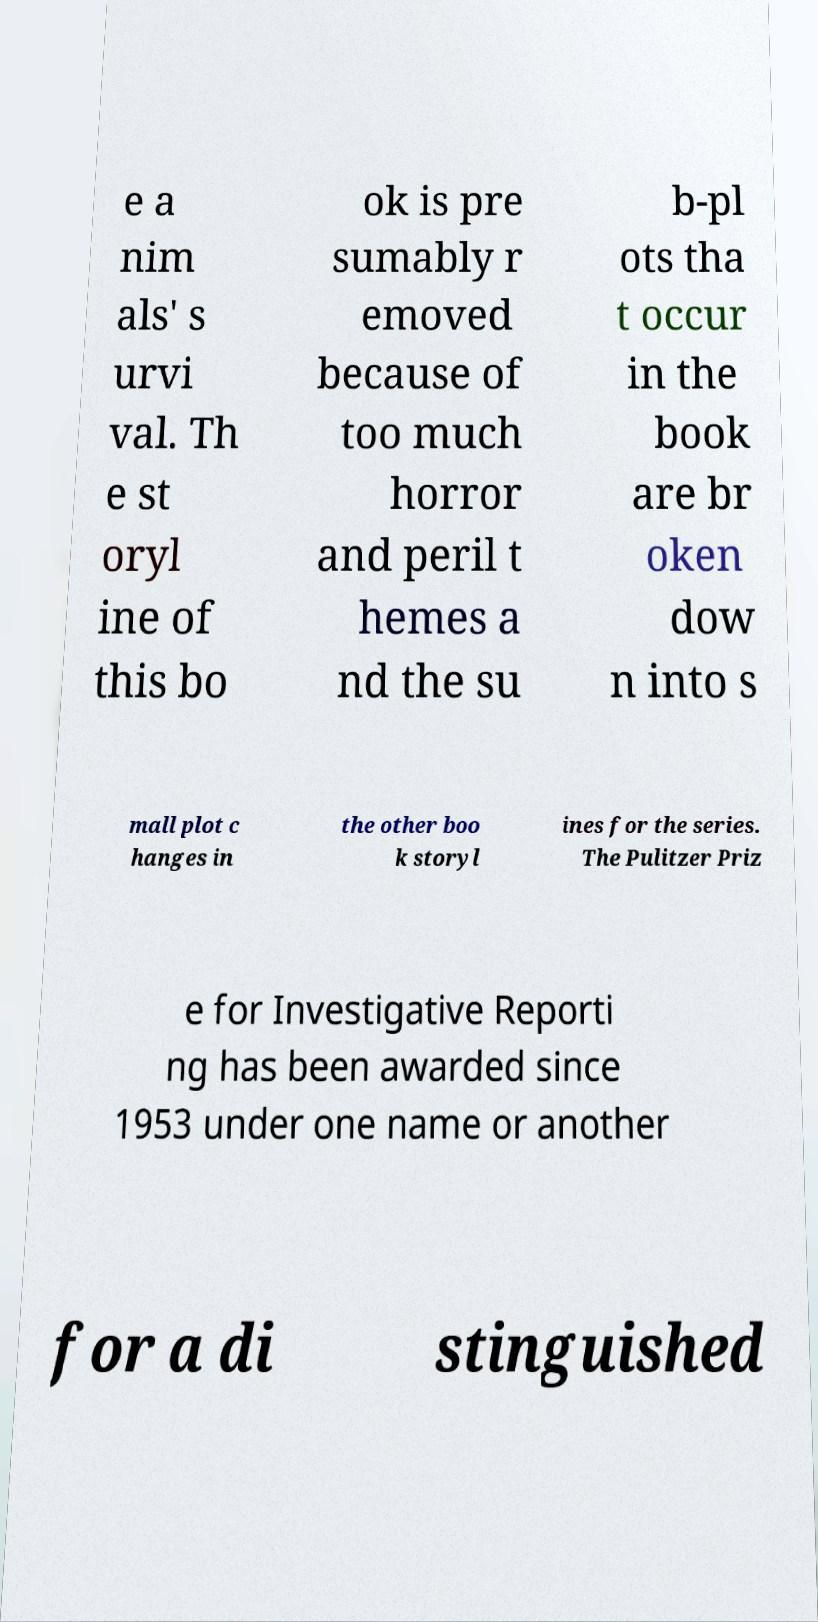Please read and relay the text visible in this image. What does it say? e a nim als' s urvi val. Th e st oryl ine of this bo ok is pre sumably r emoved because of too much horror and peril t hemes a nd the su b-pl ots tha t occur in the book are br oken dow n into s mall plot c hanges in the other boo k storyl ines for the series. The Pulitzer Priz e for Investigative Reporti ng has been awarded since 1953 under one name or another for a di stinguished 